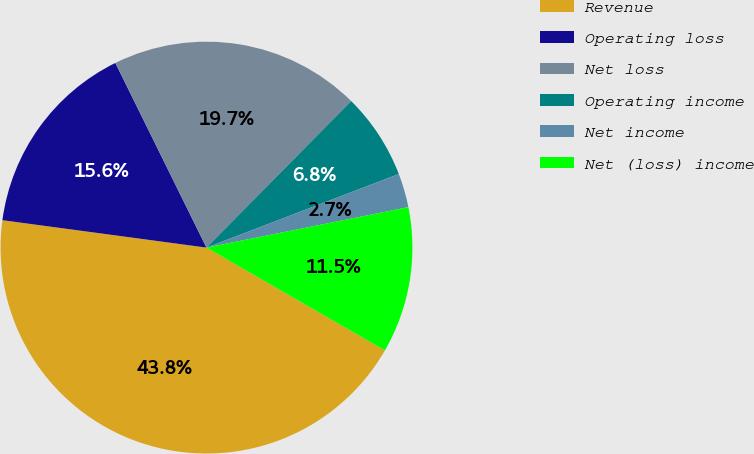Convert chart to OTSL. <chart><loc_0><loc_0><loc_500><loc_500><pie_chart><fcel>Revenue<fcel>Operating loss<fcel>Net loss<fcel>Operating income<fcel>Net income<fcel>Net (loss) income<nl><fcel>43.81%<fcel>15.58%<fcel>19.7%<fcel>6.78%<fcel>2.67%<fcel>11.47%<nl></chart> 